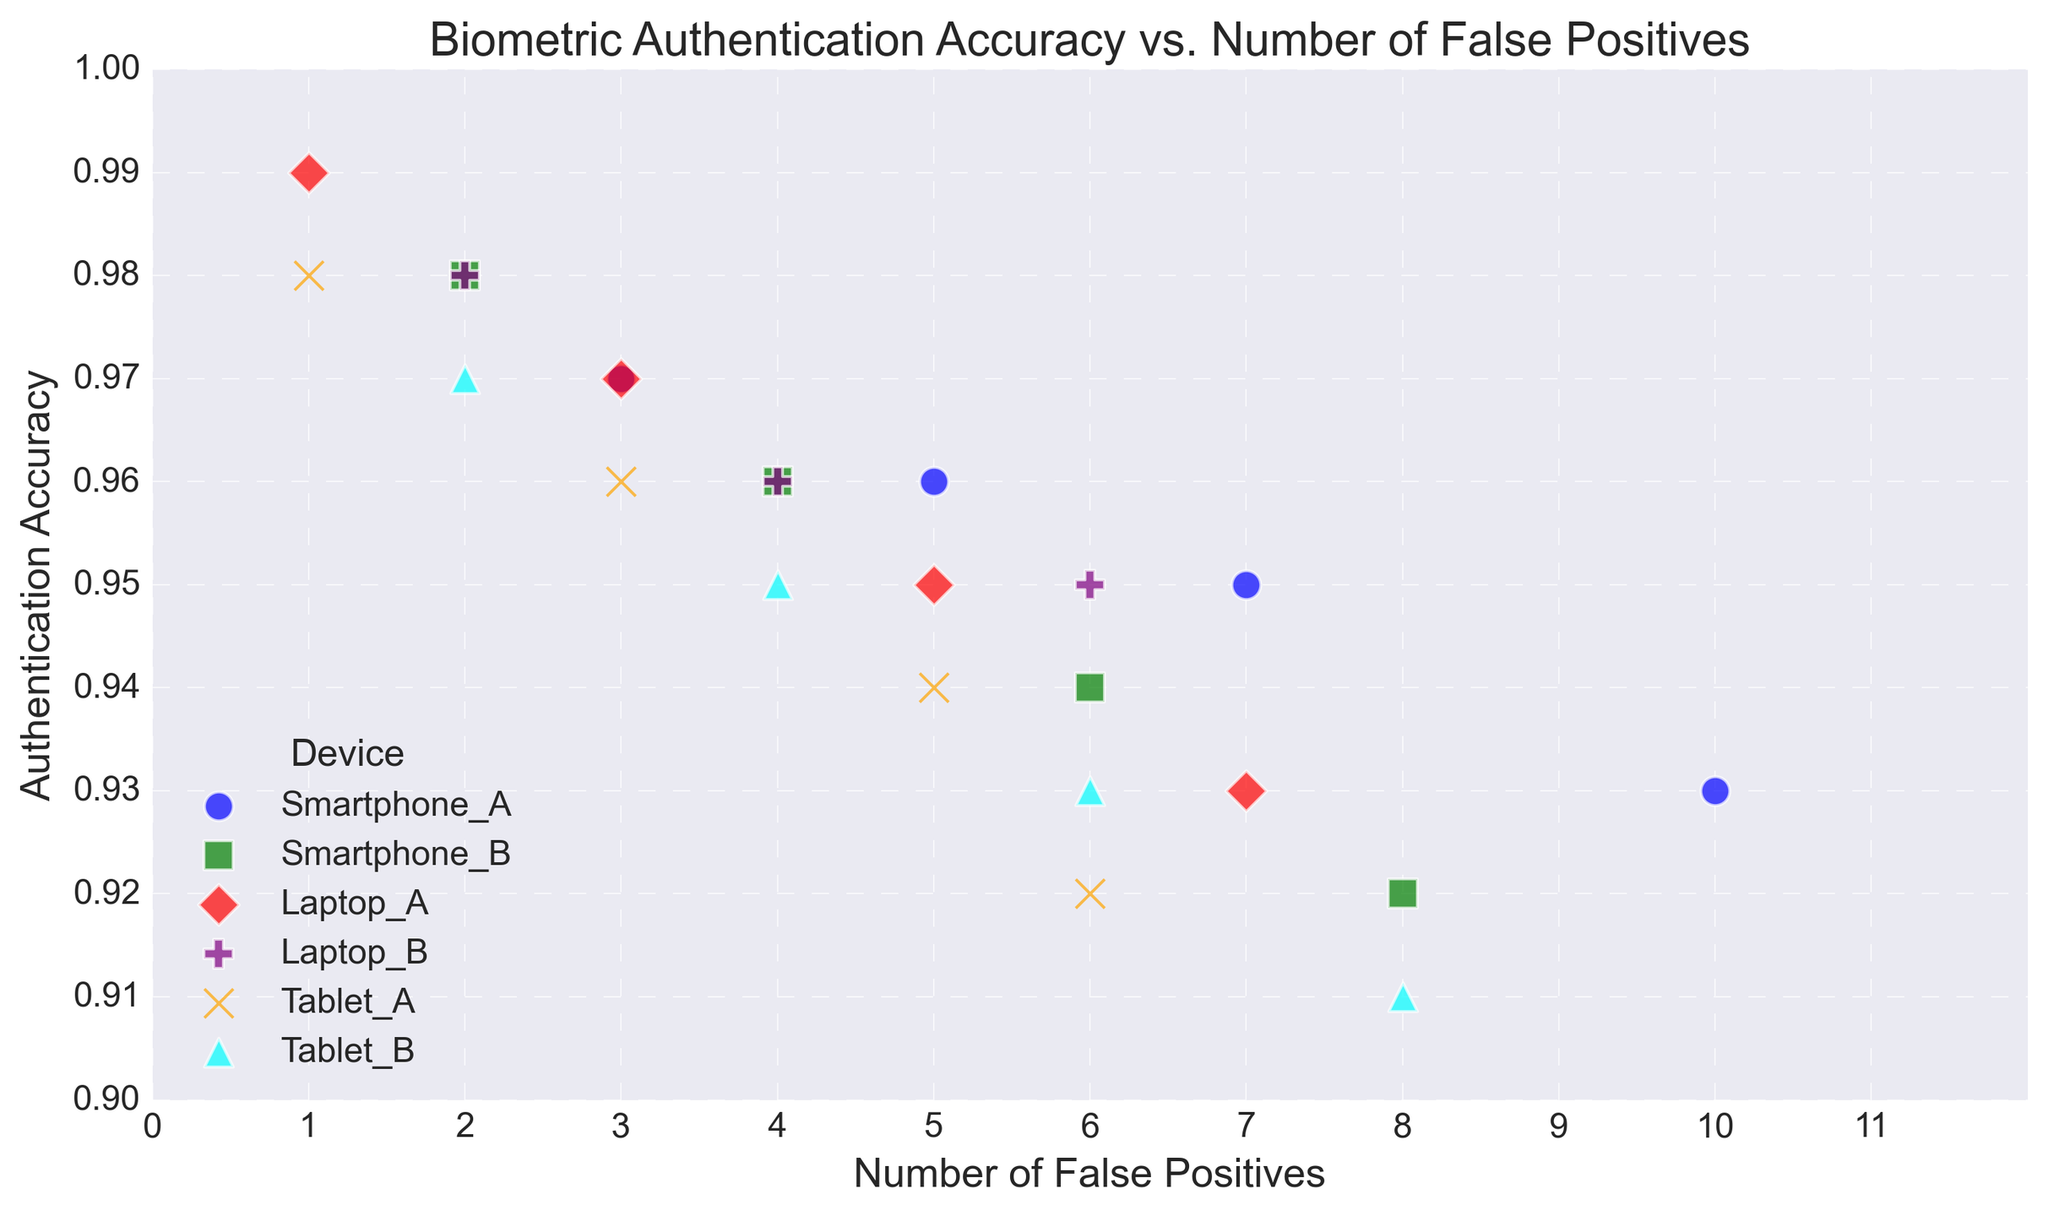Which device has the highest authentication accuracy with the lowest number of false positives? Examine the y-axis for highest accuracy and check which device aligns with the lowest number of false positives on the x-axis. Laptop_A has the highest accuracy of 0.99 with the lowest false positives (1).
Answer: Laptop_A By how much does the accuracy of Smartphone_A drop when the number of false positives increases from 3 to 10? First, identify the accuracy values at 3 false positives (0.97) and at 10 false positives (0.93) for Smartphone_A. Calculate the difference: 0.97 - 0.93 = 0.04.
Answer: 0.04 Comparing all devices, which device has the steepest decline in accuracy per additional false positive? Identify the device with the largest decrease in accuracy across the x-axis. Smartphone_B drops from 0.98 to 0.92 as false positives increase from 2 to 8, showing the steepest decline of 0.06 across 6 units.
Answer: Smartphone_B Which two devices have equal authentication accuracy levels at any number of false positives? Look for overlapping y-values across the x-axis. At 6 false positives, the accuracy for Laptop_B and Tablet_A is both 0.95.
Answer: Laptop_B and Tablet_A What is the trend of authentication accuracy as the number of false positives increases for Tablet_B? Observe the scatter points for Tablet_B (cyan) from x=2 to x=8. The accuracy consistently decreases: 0.97, 0.95, 0.93, and 0.91.
Answer: Decreasing Which device maintains an authentication accuracy above 0.95 at the highest number of false positives evaluated in the plot? Check each device's scatter points for the highest value of false positives and their accuracy. Laptop_B maintains an accuracy above 0.95 at 6 false positives.
Answer: Laptop_B On average, how much does the accuracy change per false positive for Laptop_A from 1 to 7 false positives? Calculate the difference in accuracy from 1 to 7 false positives (0.99 - 0.93 = 0.06) and divide by the increase in false positives (7 - 1 = 6). Average change = 0.06 / 6 = 0.01.
Answer: 0.01 per false positive 